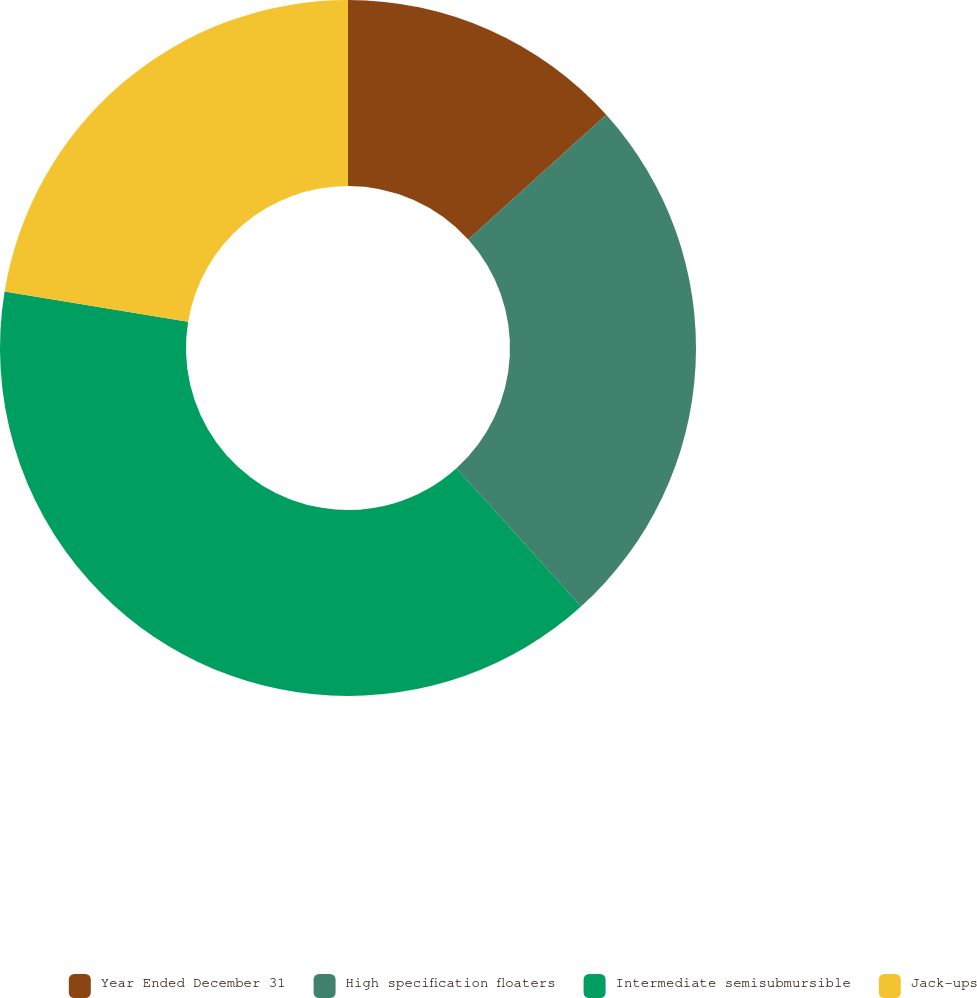Convert chart to OTSL. <chart><loc_0><loc_0><loc_500><loc_500><pie_chart><fcel>Year Ended December 31<fcel>High specification floaters<fcel>Intermediate semisubmursible<fcel>Jack-ups<nl><fcel>13.31%<fcel>25.01%<fcel>39.27%<fcel>22.41%<nl></chart> 